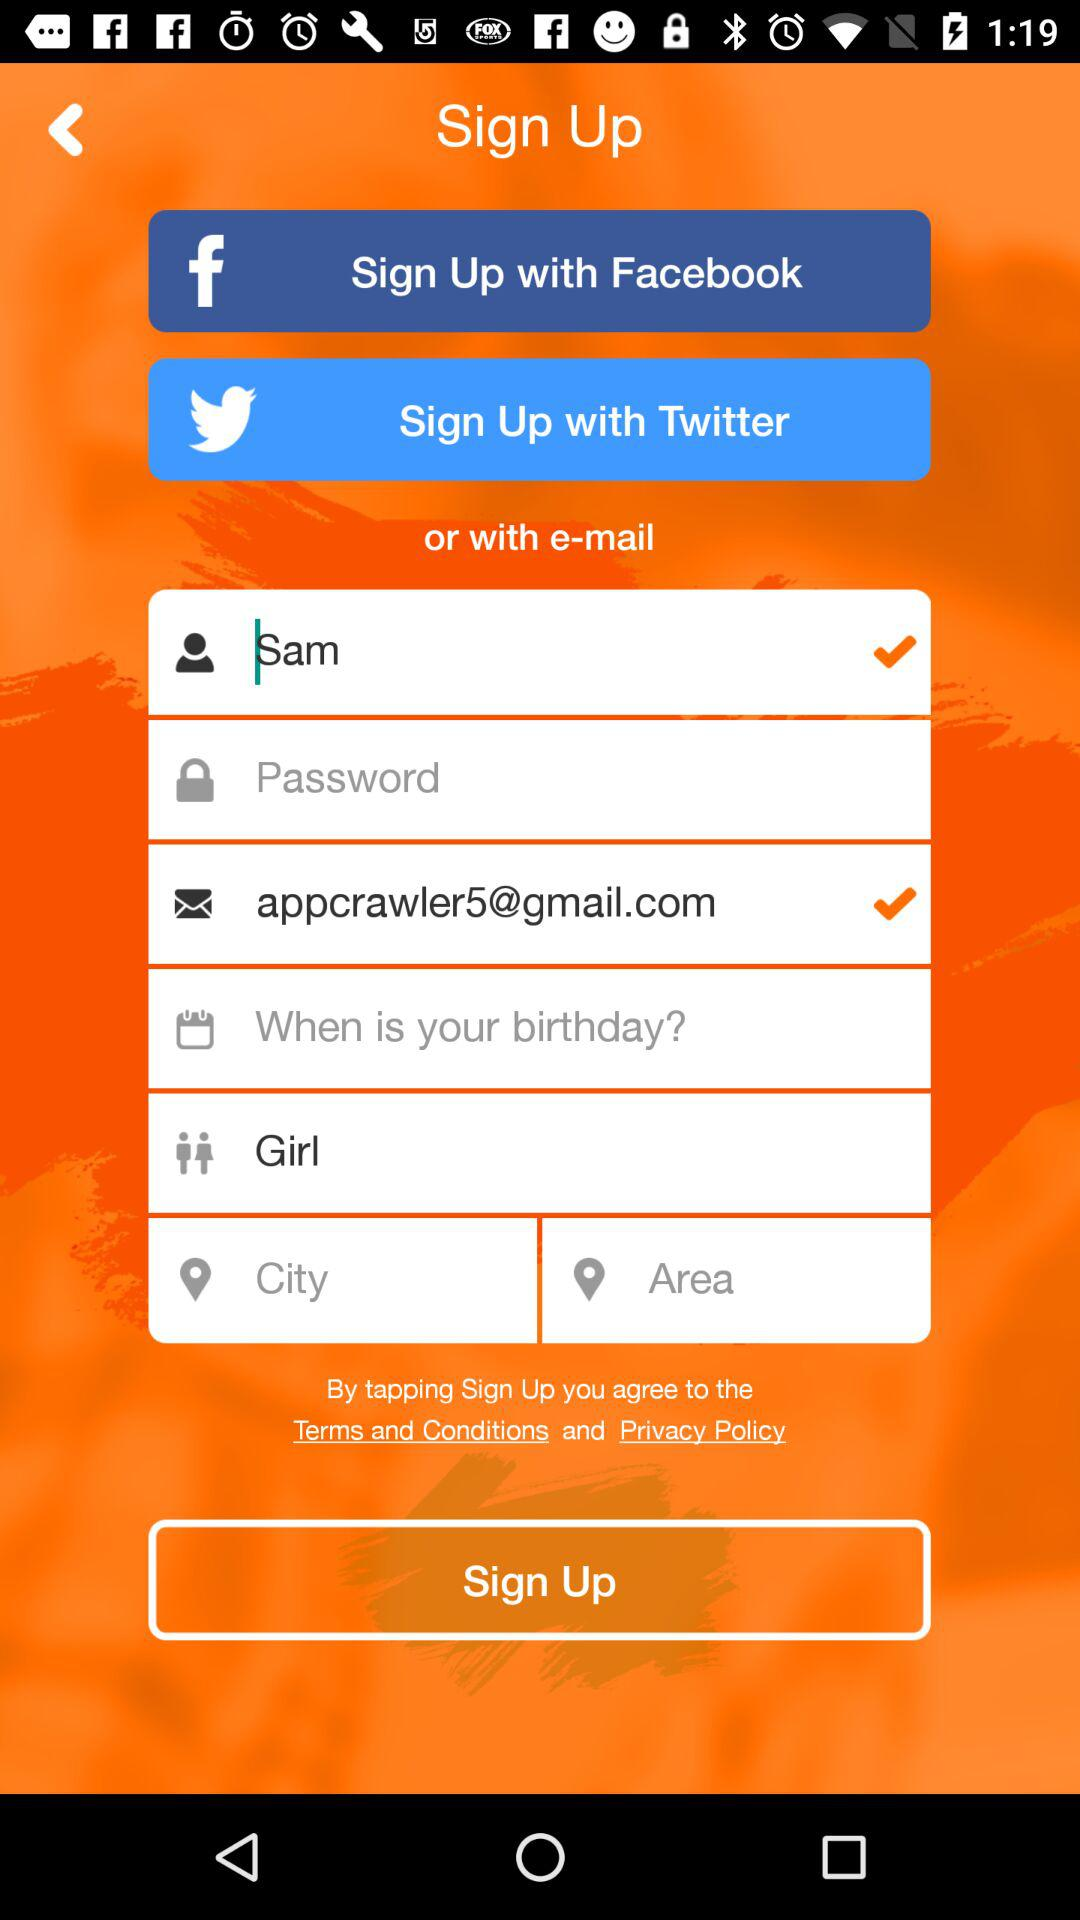What is the selected gender?
Answer the question using a single word or phrase. It's a girl. 